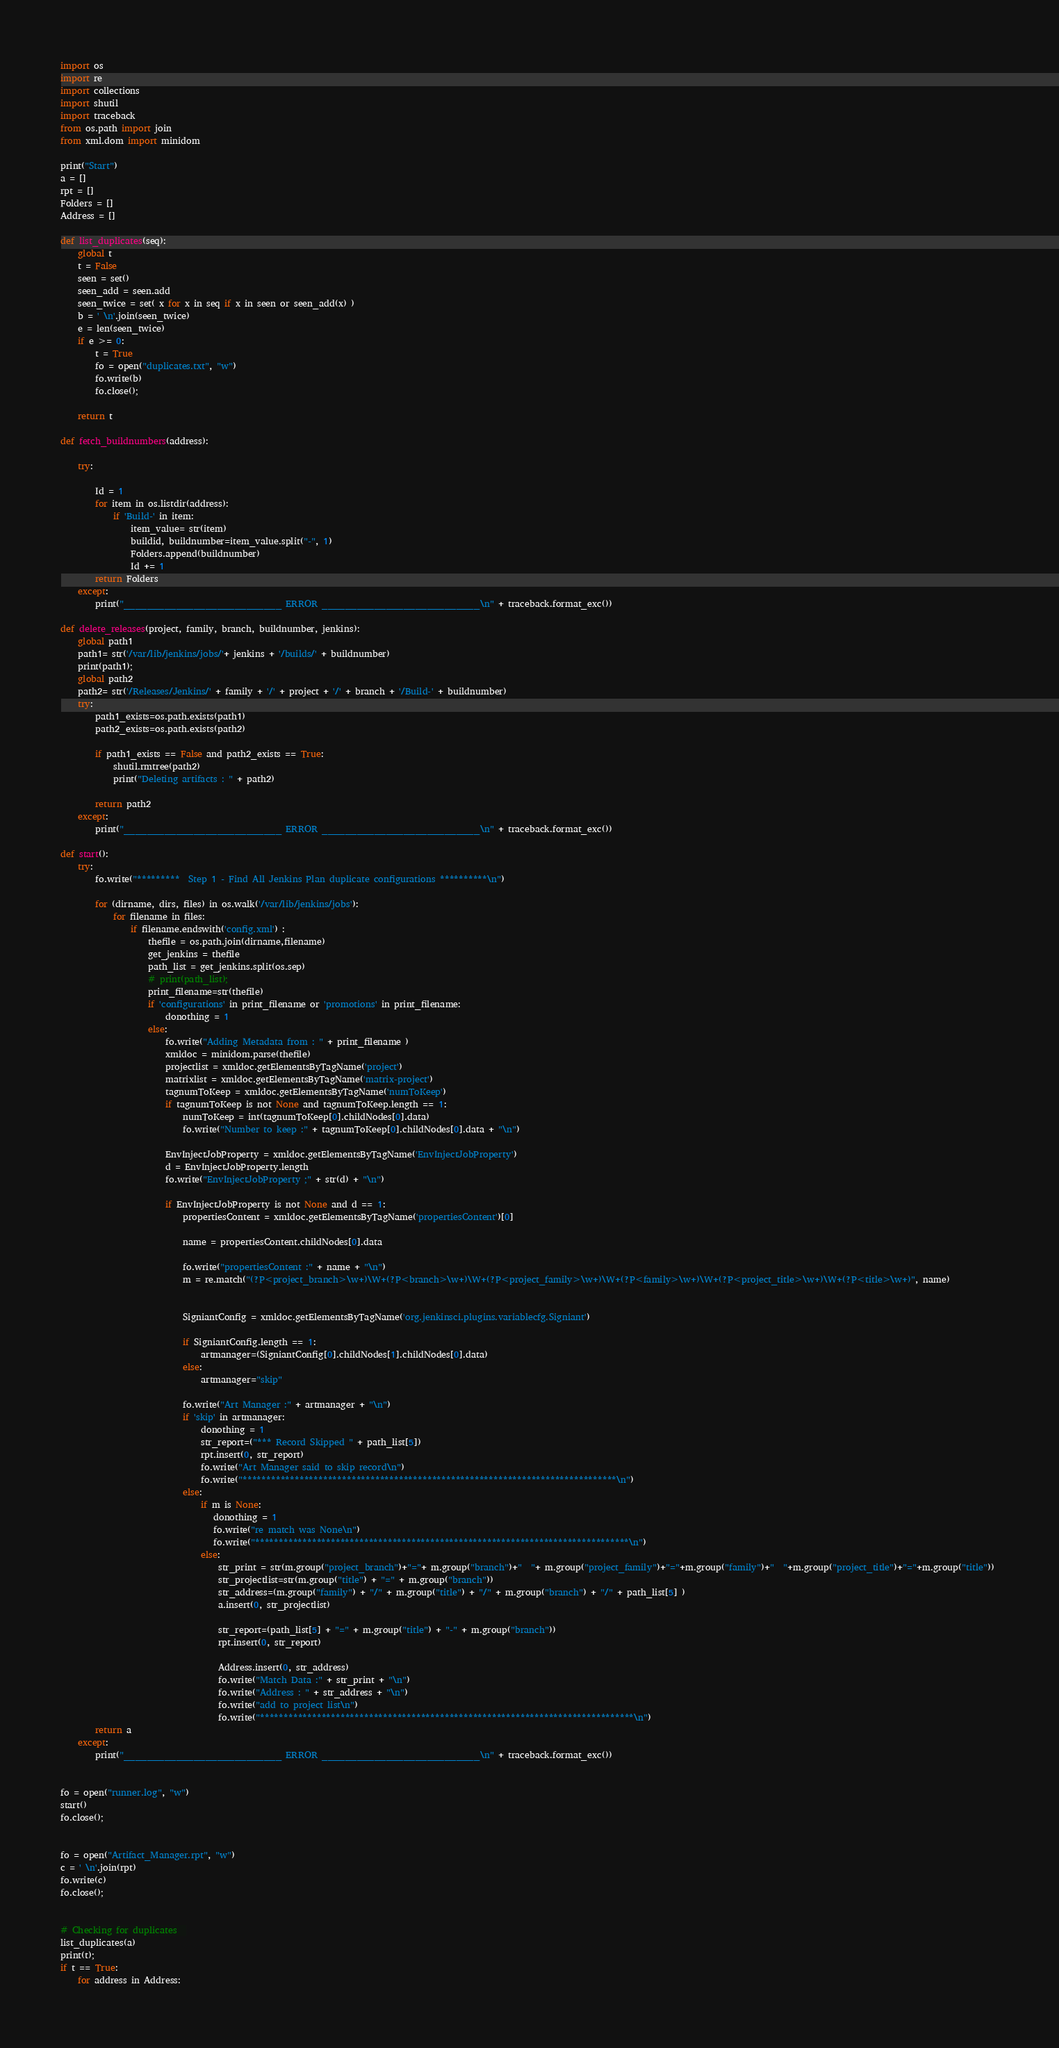Convert code to text. <code><loc_0><loc_0><loc_500><loc_500><_Python_>import os
import re
import collections
import shutil
import traceback
from os.path import join
from xml.dom import minidom

print("Start")
a = []
rpt = []
Folders = []
Address = []

def list_duplicates(seq):
    global t
    t = False
    seen = set()
    seen_add = seen.add
    seen_twice = set( x for x in seq if x in seen or seen_add(x) )
    b = ' \n'.join(seen_twice)
    e = len(seen_twice)
    if e >= 0:
        t = True
        fo = open("duplicates.txt", "w")
        fo.write(b)
        fo.close();
  
    return t

def fetch_buildnumbers(address):

    try:

        Id = 1
        for item in os.listdir(address):
            if 'Build-' in item:
                item_value= str(item)
                buildid, buildnumber=item_value.split("-", 1)
                Folders.append(buildnumber)
                Id += 1         
        return Folders
    except:
        print("___________________________ ERROR ___________________________\n" + traceback.format_exc())

def delete_releases(project, family, branch, buildnumber, jenkins):
    global path1
    path1= str('/var/lib/jenkins/jobs/'+ jenkins + '/builds/' + buildnumber)
    print(path1);
    global path2
    path2= str('/Releases/Jenkins/' + family + '/' + project + '/' + branch + '/Build-' + buildnumber) 
    try:
        path1_exists=os.path.exists(path1) 
        path2_exists=os.path.exists(path2)
     
        if path1_exists == False and path2_exists == True:
            shutil.rmtree(path2)
            print("Deleting artifacts : " + path2)

        return path2
    except:
        print("___________________________ ERROR ___________________________\n" + traceback.format_exc())

def start():
    try:
        fo.write("*********  Step 1 - Find All Jenkins Plan duplicate configurations **********\n")

        for (dirname, dirs, files) in os.walk('/var/lib/jenkins/jobs'):
            for filename in files:
                if filename.endswith('config.xml') :
                    thefile = os.path.join(dirname,filename)
                    get_jenkins = thefile
                    path_list = get_jenkins.split(os.sep)
                    # print(path_list);
                    print_filename=str(thefile)
                    if 'configurations' in print_filename or 'promotions' in print_filename:
                        donothing = 1
                    else:
                        fo.write("Adding Metadata from : " + print_filename )
                        xmldoc = minidom.parse(thefile)
                        projectlist = xmldoc.getElementsByTagName('project')
                        matrixlist = xmldoc.getElementsByTagName('matrix-project')
                        tagnumToKeep = xmldoc.getElementsByTagName('numToKeep')
                        if tagnumToKeep is not None and tagnumToKeep.length == 1:
                            numToKeep = int(tagnumToKeep[0].childNodes[0].data)
                            fo.write("Number to keep :" + tagnumToKeep[0].childNodes[0].data + "\n")
               
                        EnvInjectJobProperty = xmldoc.getElementsByTagName('EnvInjectJobProperty')
                        d = EnvInjectJobProperty.length
                        fo.write("EnvInjectJobProperty ;" + str(d) + "\n")

                        if EnvInjectJobProperty is not None and d == 1:
                            propertiesContent = xmldoc.getElementsByTagName('propertiesContent')[0]

                            name = propertiesContent.childNodes[0].data

                            fo.write("propertiesContent :" + name + "\n")
                            m = re.match("(?P<project_branch>\w+)\W+(?P<branch>\w+)\W+(?P<project_family>\w+)\W+(?P<family>\w+)\W+(?P<project_title>\w+)\W+(?P<title>\w+)", name)
                        
                    
                            SigniantConfig = xmldoc.getElementsByTagName('org.jenkinsci.plugins.variablecfg.Signiant')
                           
                            if SigniantConfig.length == 1:
                                artmanager=(SigniantConfig[0].childNodes[1].childNodes[0].data)
                            else:
                                artmanager="skip"

                            fo.write("Art Manager :" + artmanager + "\n")
                            if 'skip' in artmanager:
                                donothing = 1
                                str_report=("*** Record Skipped " + path_list[5])
                                rpt.insert(0, str_report)
                                fo.write("Art Manager said to skip record\n")
                                fo.write("*******************************************************************************\n")
                            else:
                                if m is None:
                                   donothing = 1
                                   fo.write("re match was None\n")
                                   fo.write("*******************************************************************************\n")
                                else:
                                    str_print = str(m.group("project_branch")+"="+ m.group("branch")+"  "+ m.group("project_family")+"="+m.group("family")+"  "+m.group("project_title")+"="+m.group("title")) 
                                    str_projectlist=str(m.group("title") + "=" + m.group("branch"))
                                    str_address=(m.group("family") + "/" + m.group("title") + "/" + m.group("branch") + "/" + path_list[5] )
                                    a.insert(0, str_projectlist) 
                                    
                                    str_report=(path_list[5] + "=" + m.group("title") + "-" + m.group("branch"))
                                    rpt.insert(0, str_report)
                                    
                                    Address.insert(0, str_address)
                                    fo.write("Match Data :" + str_print + "\n")
                                    fo.write("Address : " + str_address + "\n")
                                    fo.write("add to project list\n")
                                    fo.write("*******************************************************************************\n")
        return a                            
    except:
        print("___________________________ ERROR ___________________________\n" + traceback.format_exc())     


fo = open("runner.log", "w")
start()
fo.close();   


fo = open("Artifact_Manager.rpt", "w")
c = ' \n'.join(rpt)
fo.write(c)
fo.close();


# Checking for duplicates  
list_duplicates(a)
print(t);
if t == True:
    for address in Address: </code> 